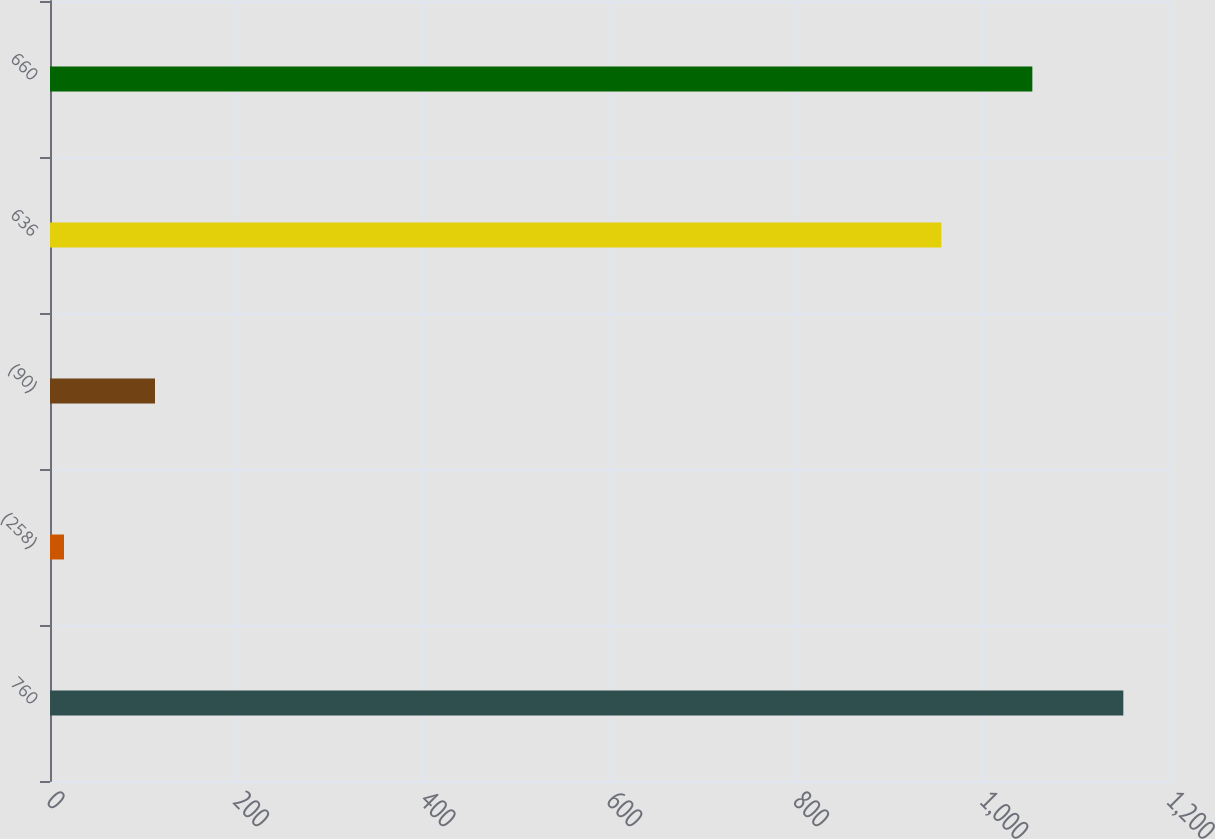Convert chart to OTSL. <chart><loc_0><loc_0><loc_500><loc_500><bar_chart><fcel>760<fcel>(258)<fcel>(90)<fcel>636<fcel>660<nl><fcel>1150<fcel>15<fcel>112.5<fcel>955<fcel>1052.5<nl></chart> 